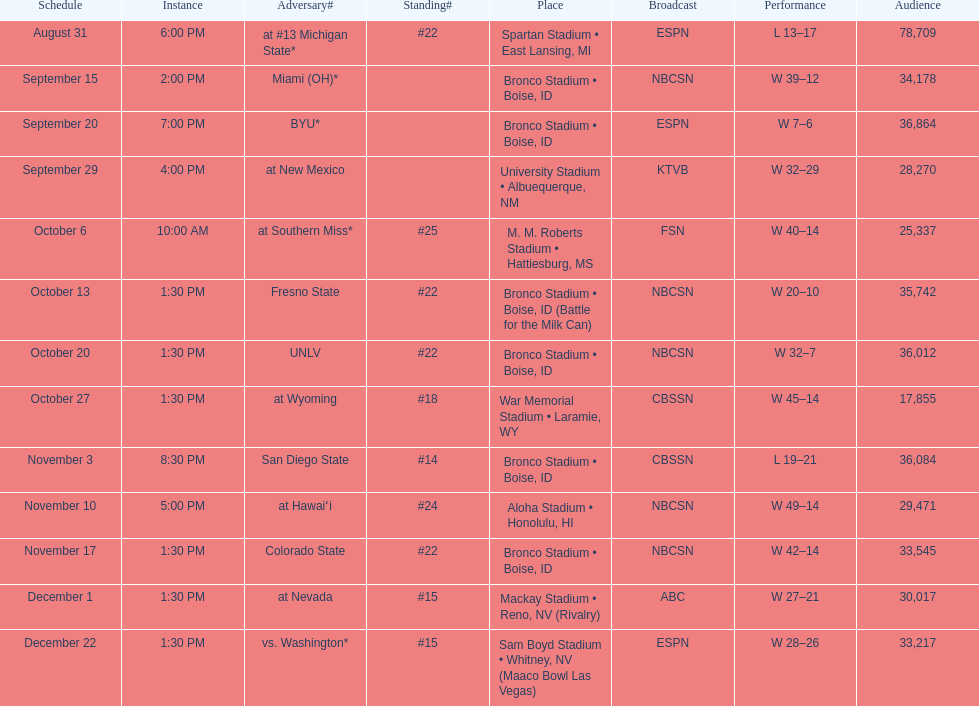Opponent broncos faced next after unlv Wyoming. 